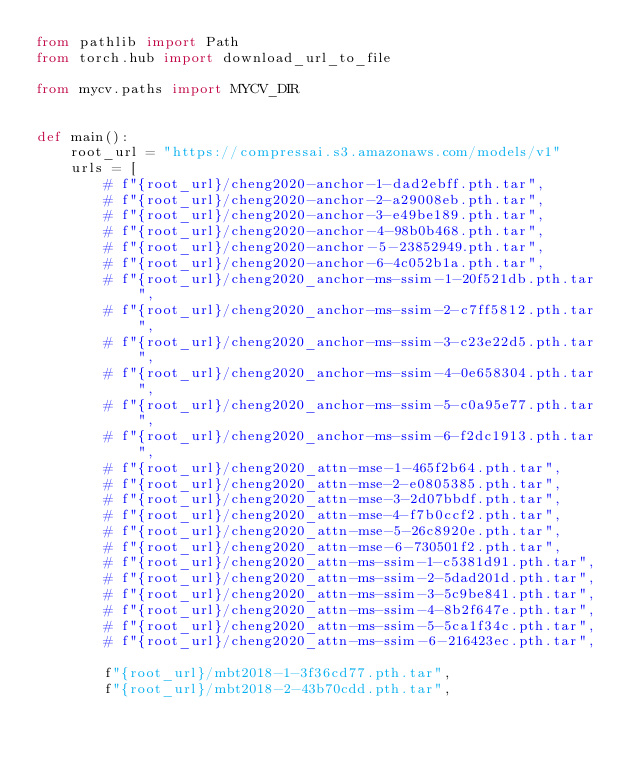Convert code to text. <code><loc_0><loc_0><loc_500><loc_500><_Python_>from pathlib import Path
from torch.hub import download_url_to_file

from mycv.paths import MYCV_DIR


def main():
    root_url = "https://compressai.s3.amazonaws.com/models/v1"
    urls = [
        # f"{root_url}/cheng2020-anchor-1-dad2ebff.pth.tar",
        # f"{root_url}/cheng2020-anchor-2-a29008eb.pth.tar",
        # f"{root_url}/cheng2020-anchor-3-e49be189.pth.tar",
        # f"{root_url}/cheng2020-anchor-4-98b0b468.pth.tar",
        # f"{root_url}/cheng2020-anchor-5-23852949.pth.tar",
        # f"{root_url}/cheng2020-anchor-6-4c052b1a.pth.tar",
        # f"{root_url}/cheng2020_anchor-ms-ssim-1-20f521db.pth.tar",
        # f"{root_url}/cheng2020_anchor-ms-ssim-2-c7ff5812.pth.tar",
        # f"{root_url}/cheng2020_anchor-ms-ssim-3-c23e22d5.pth.tar",
        # f"{root_url}/cheng2020_anchor-ms-ssim-4-0e658304.pth.tar",
        # f"{root_url}/cheng2020_anchor-ms-ssim-5-c0a95e77.pth.tar",
        # f"{root_url}/cheng2020_anchor-ms-ssim-6-f2dc1913.pth.tar",
        # f"{root_url}/cheng2020_attn-mse-1-465f2b64.pth.tar",
        # f"{root_url}/cheng2020_attn-mse-2-e0805385.pth.tar",
        # f"{root_url}/cheng2020_attn-mse-3-2d07bbdf.pth.tar",
        # f"{root_url}/cheng2020_attn-mse-4-f7b0ccf2.pth.tar",
        # f"{root_url}/cheng2020_attn-mse-5-26c8920e.pth.tar",
        # f"{root_url}/cheng2020_attn-mse-6-730501f2.pth.tar",
        # f"{root_url}/cheng2020_attn-ms-ssim-1-c5381d91.pth.tar",
        # f"{root_url}/cheng2020_attn-ms-ssim-2-5dad201d.pth.tar",
        # f"{root_url}/cheng2020_attn-ms-ssim-3-5c9be841.pth.tar",
        # f"{root_url}/cheng2020_attn-ms-ssim-4-8b2f647e.pth.tar",
        # f"{root_url}/cheng2020_attn-ms-ssim-5-5ca1f34c.pth.tar",
        # f"{root_url}/cheng2020_attn-ms-ssim-6-216423ec.pth.tar",

        f"{root_url}/mbt2018-1-3f36cd77.pth.tar",
        f"{root_url}/mbt2018-2-43b70cdd.pth.tar",</code> 